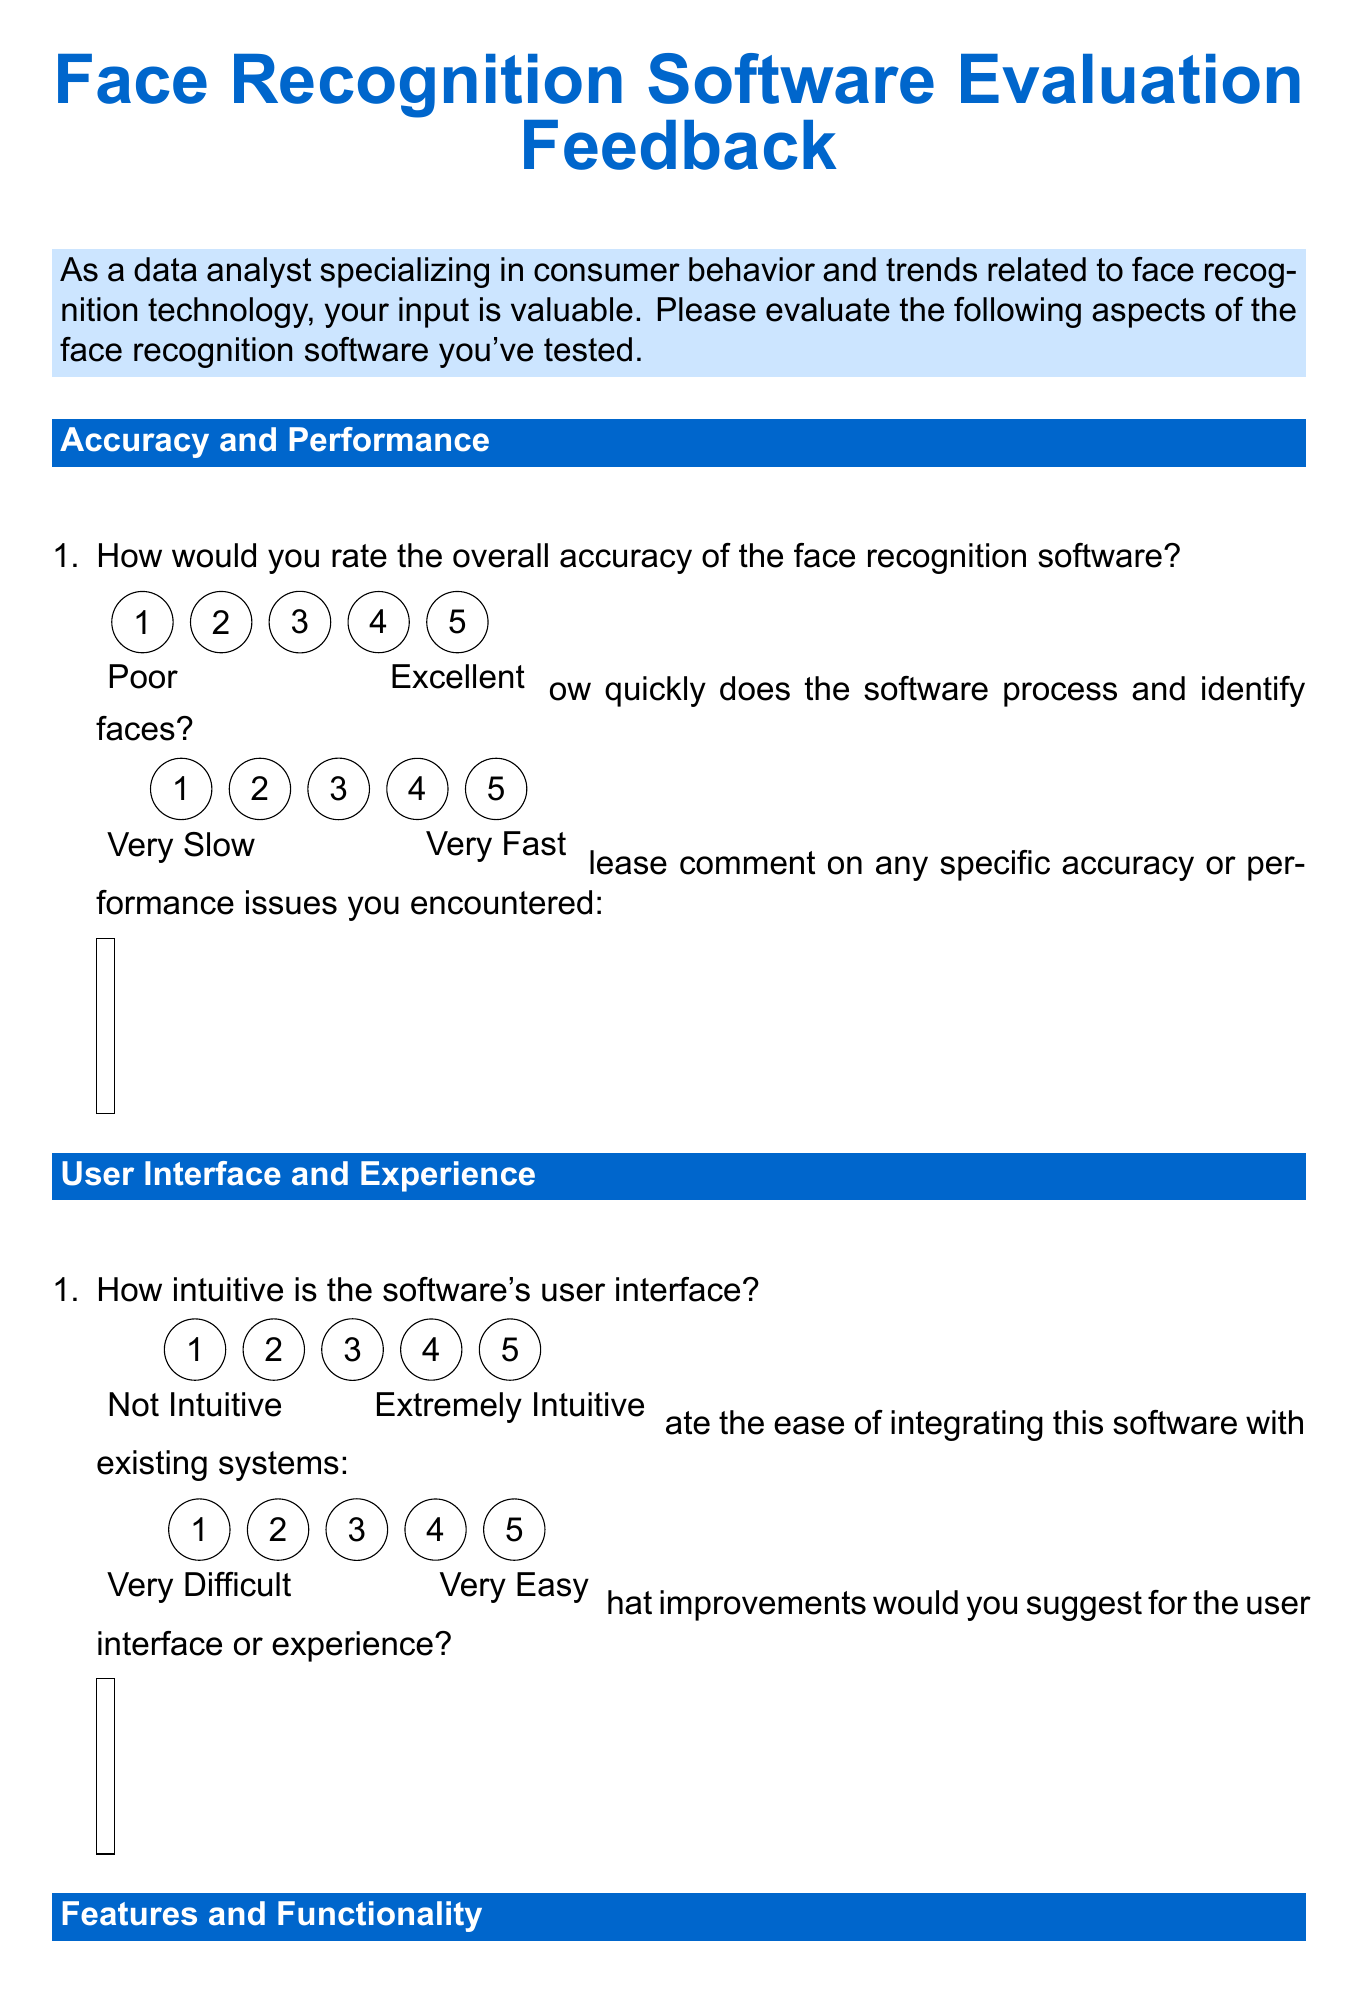How many sections are in the feedback form? The feedback form includes five sections: Accuracy and Performance, User Interface and Experience, Features and Functionality, Data Privacy and Security, and Scalability and Future Potential, as well as an Overall Assessment section.
Answer: 6 What is the maximum rating for the overall accuracy of the face recognition software? The maximum rating for the accuracy is given in a rating scale of 1 to 5.
Answer: 5 What type of question asks for comments on accuracy or performance issues? The document includes a text area question that prompts for detailed input on specific issues encountered during the evaluation.
Answer: Text area How likely are users to recommend the software, on a scale from 0 to 10? The recommendation likelihood is assessed on a scale that ranges from 0 (not at all likely) to 10 (extremely likely).
Answer: 0 to 10 What additional comments can users provide? An open text area is provided for any additional insights or comments about the software, allowing for qualitative feedback.
Answer: Text area How would you rate the software's data encryption measures? This question asks respondents to evaluate the effectiveness of the software's data encryption and protections, rated from 1 to 5.
Answer: Rating from 1 to 5 